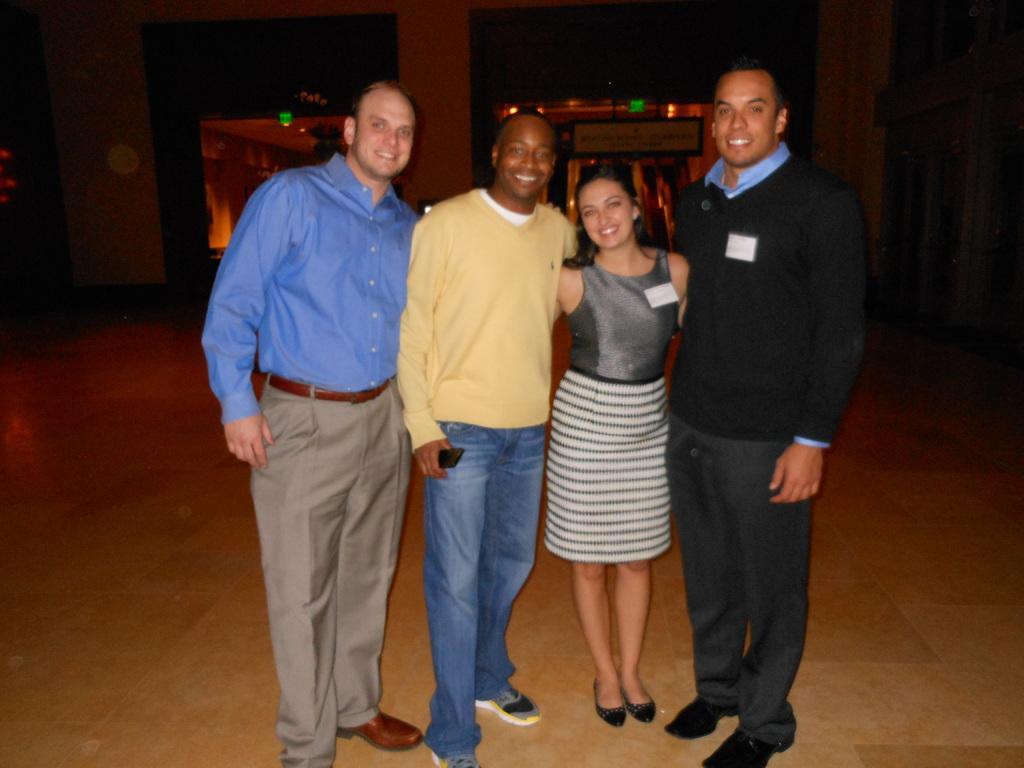Describe this image in one or two sentences. Here I can see three men and a woman are standing, smiling and giving pose for the picture. In the background, I can see a building and few lights in the dark. 